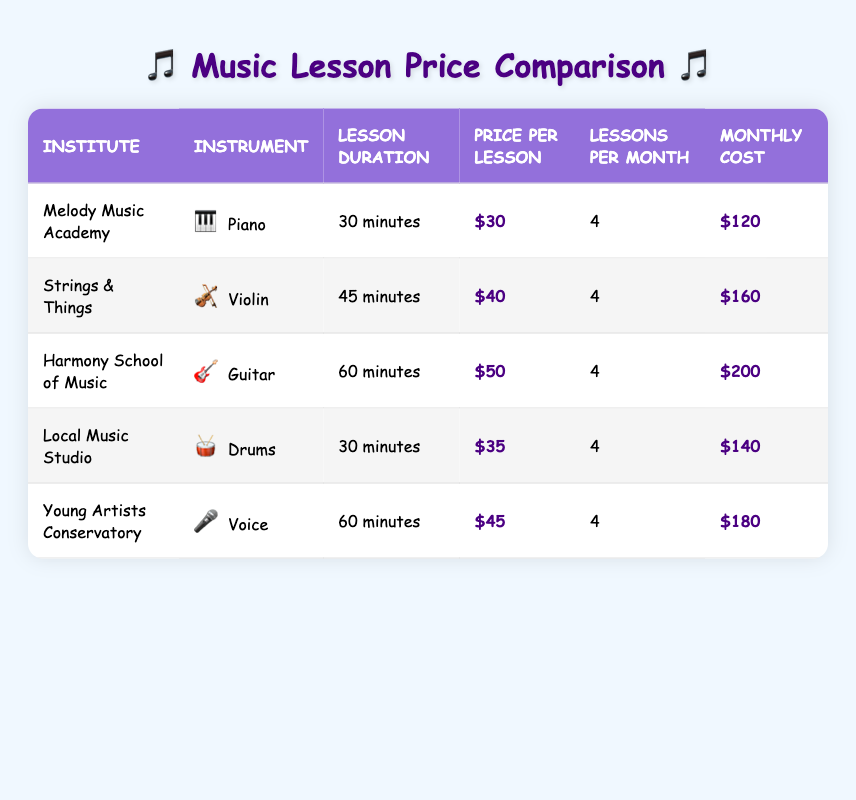What's the price per lesson for piano at Melody Music Academy? The price for a piano lesson at Melody Music Academy is listed under the "Price per Lesson" column, which shows $30.
Answer: 30 Which institute offers drum lessons, and how much does it cost per month? The "Local Music Studio" offers drum lessons for $35 per lesson, leading to a total monthly cost of $140 as seen in their respective rows.
Answer: Local Music Studio; 140 How many minutes long is a guitar lesson at Harmony School of Music? The duration for a guitar lesson is displayed under the "Lesson Duration" column for Harmony School of Music, which is 60 minutes.
Answer: 60 minutes Which instrument has the most expensive total monthly cost, and how much is it? By examining the "Total Monthly Cost" column, guitar lessons at Harmony School of Music are the highest at $200, which is greater than the other instruments' costs.
Answer: Guitar; 200 What is the average price per lesson across all instruments? Add the prices: 30 + 40 + 50 + 35 + 45 = 200. There are 5 lessons, so the average price is 200/5 = 40.
Answer: 40 Is the total monthly cost for violin lessons at Strings & Things greater than the total cost for voice lessons at Young Artists Conservatory? The total monthly costs are $160 for violin lessons and $180 for voice lessons. Since 180 is greater than 160, the statement is true.
Answer: Yes Which instrument has the longest lesson duration and how long is it? The longest lesson duration is for guitar lessons at Harmony School of Music, which lasts 60 minutes. This is confirmed by checking all lesson durations in the table.
Answer: Guitar; 60 minutes How much cheaper is the monthly cost of piano lessons compared to guitar lessons? The monthly cost for piano lessons is $120 and for guitar lessons, it is $200. Thus, the difference is 200 - 120 = 80.
Answer: 80 How many more total monthly costs are there for voice lessons than for drum lessons? The total monthly cost for voice lessons is $180, and for drum lessons, it is $140. The difference is 180 - 140 = 40.
Answer: 40 